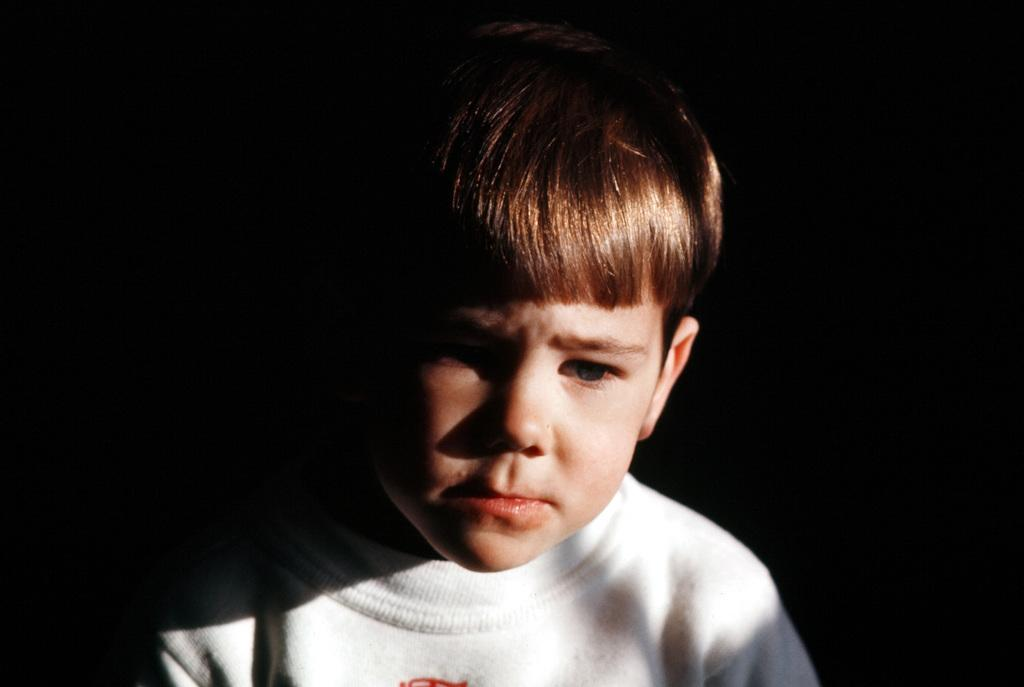Who is the main subject in the image? There is a boy in the image. What is the boy wearing? The boy is wearing a white T-shirt. How would you describe the overall lighting or color of the image? The background of the image appears dark. What is the boy saying good-bye to in the image? There is no indication in the image that the boy is saying good-bye to anyone or anything. What relation does the boy have to the person taking the photo? The image does not provide any information about the relationship between the boy and the person taking the photo. Where is the boy located in the image? The boy is the main subject in the image, and his location is not specified beyond being in the image itself. 